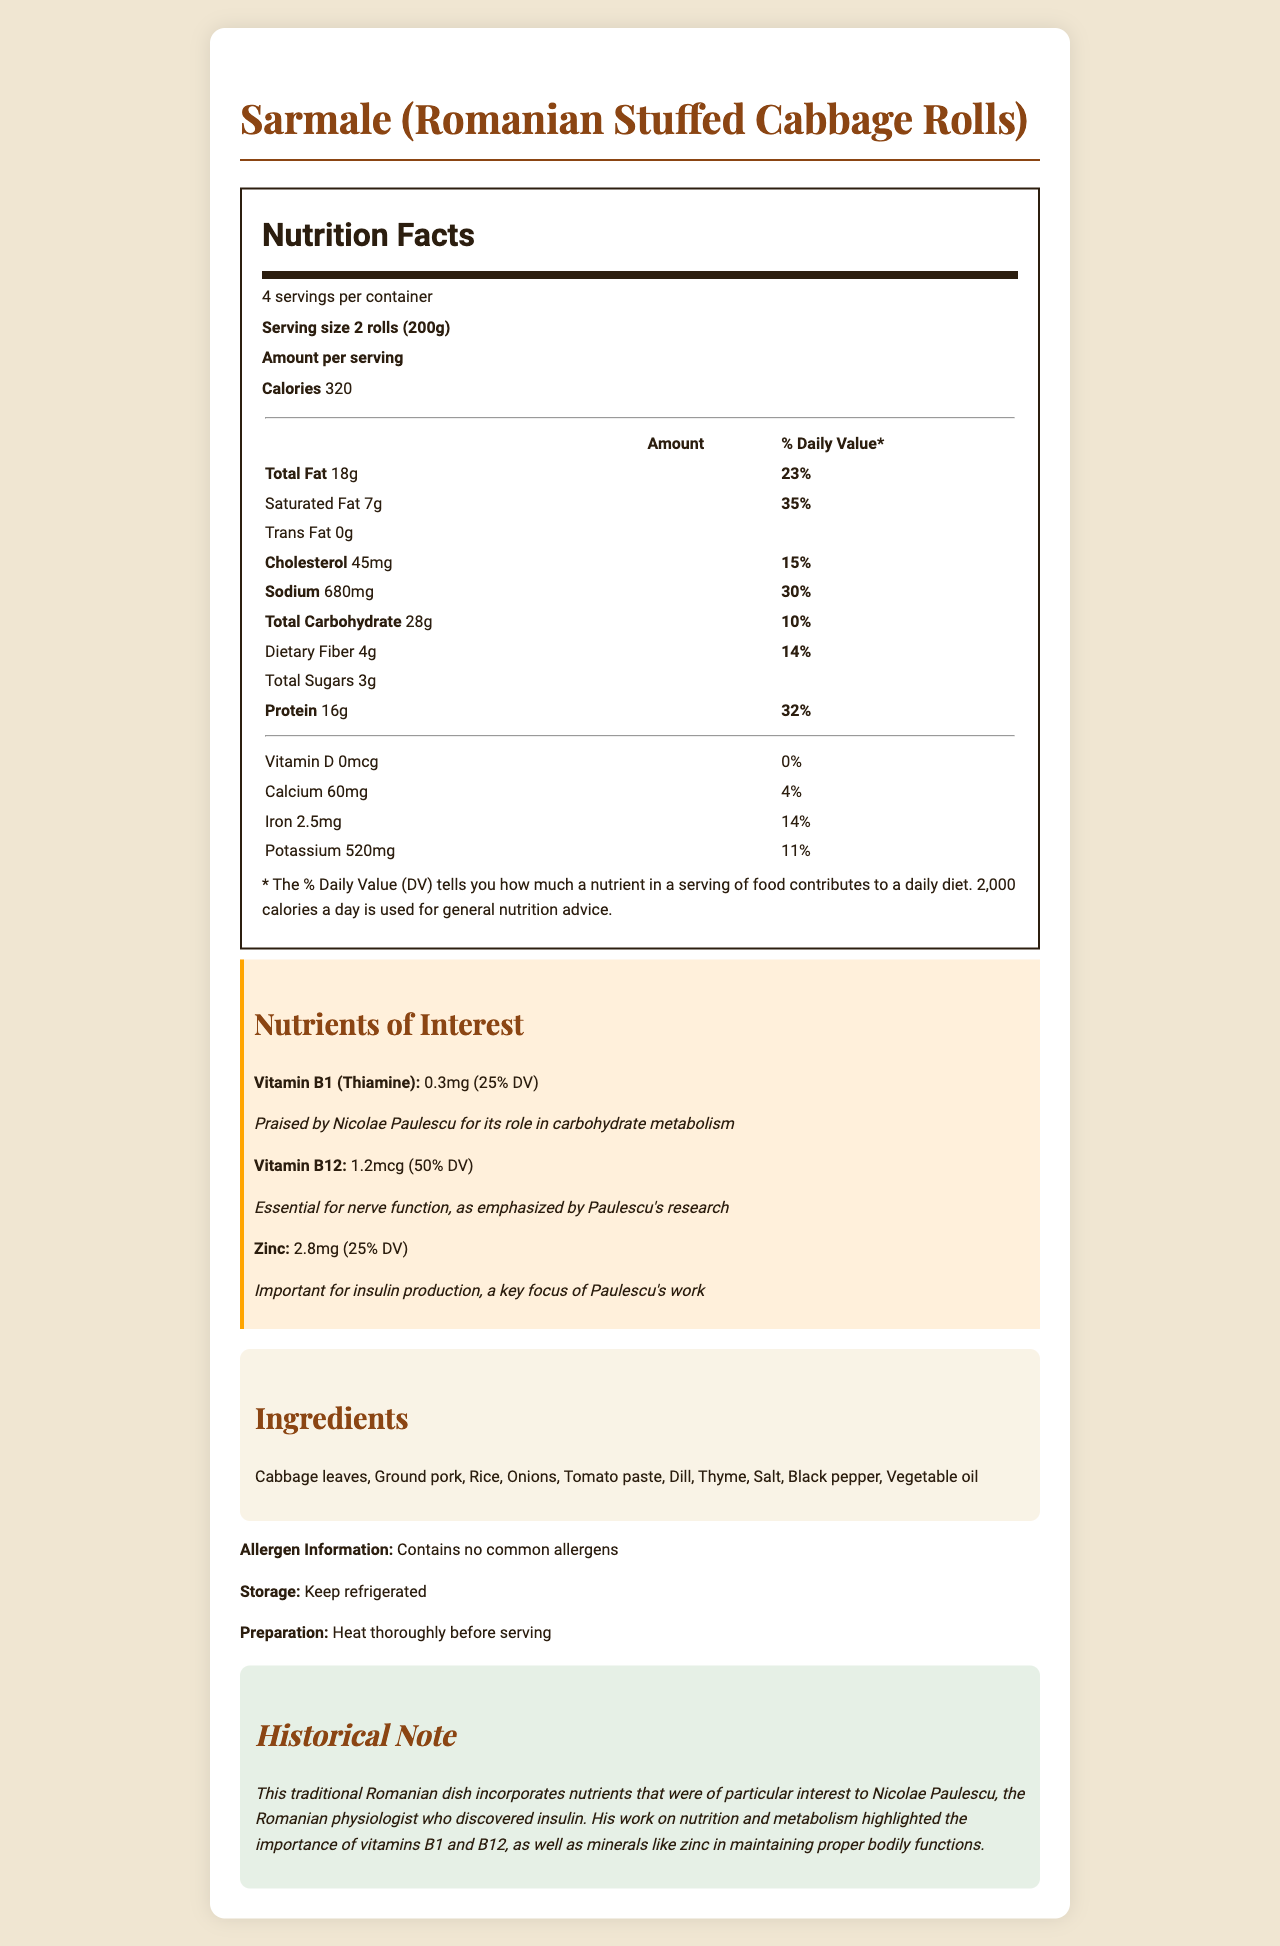what is the serving size for Sarmale? The document specifies that the serving size for Sarmale is 2 rolls, totaling 200 grams.
Answer: 2 rolls (200g) how many servings per container does the Sarmale dish have? The document states that there are 4 servings per container.
Answer: 4 servings what is the amount of protein per serving? The document mentions that there are 16 grams of protein per serving.
Answer: 16g what historical Romanian dish is described in the document? The dish described in the document is Sarmale, which are Romanian stuffed cabbage rolls.
Answer: Sarmale (Romanian Stuffed Cabbage Rolls) what is the main historical figure associated with the nutrients described in this dish? The document mentions Nicolae Paulescu, the Romanian physiologist who discovered insulin, and links his work to the nutrients discussed.
Answer: Nicolae Paulescu which nutrient has the highest % Daily Value (DV) in this dish? A. Vitamin B1 B. Vitamin B12 C. Zinc The document shows that Vitamin B12 has a Daily Value of 50%, which is the highest among the mentioned nutrients.
Answer: B. Vitamin B12 which of the following is a key focus of Nicolae Paulescu’s work? A. Dietary Fiber B. Zinc C. Vitamin D The document notes that zinc is important for insulin production, a key focus of Paulescu’s work.
Answer: B. Zinc does this dish contain common allergens? The document states that the dish contains no common allergens.
Answer: No describe the historical significance of this traditional Romanian dish in relation to Nicolae Paulescu's work. The document provides details about the nutrients in Sarmale and connects them to Paulescu's research, explaining their relevance to metabolism and insulin production.
Answer: This traditional Romanian dish, Sarmale, incorporates several nutrients that were of particular interest to Nicolae Paulescu, the Romanian physiologist who discovered insulin. His work on nutrition and metabolism highlighted the importance of vitamins B1 and B12, as well as minerals like zinc in maintaining proper bodily functions. how many grams of total fat does one serving of Sarmale contain? The document indicates that one serving of Sarmale contains 18 grams of total fat.
Answer: 18g what is the historical role of vitamin B1 according to Paulescu? The document mentions that vitamin B1 (Thiamine) was praised by Nicolae Paulescu for its role in carbohydrate metabolism.
Answer: Carbohydrate metabolism can you determine the exact age of Nicolae Paulescu from the document? The document does not provide information about Nicolae Paulescu's age.
Answer: Cannot be determined 